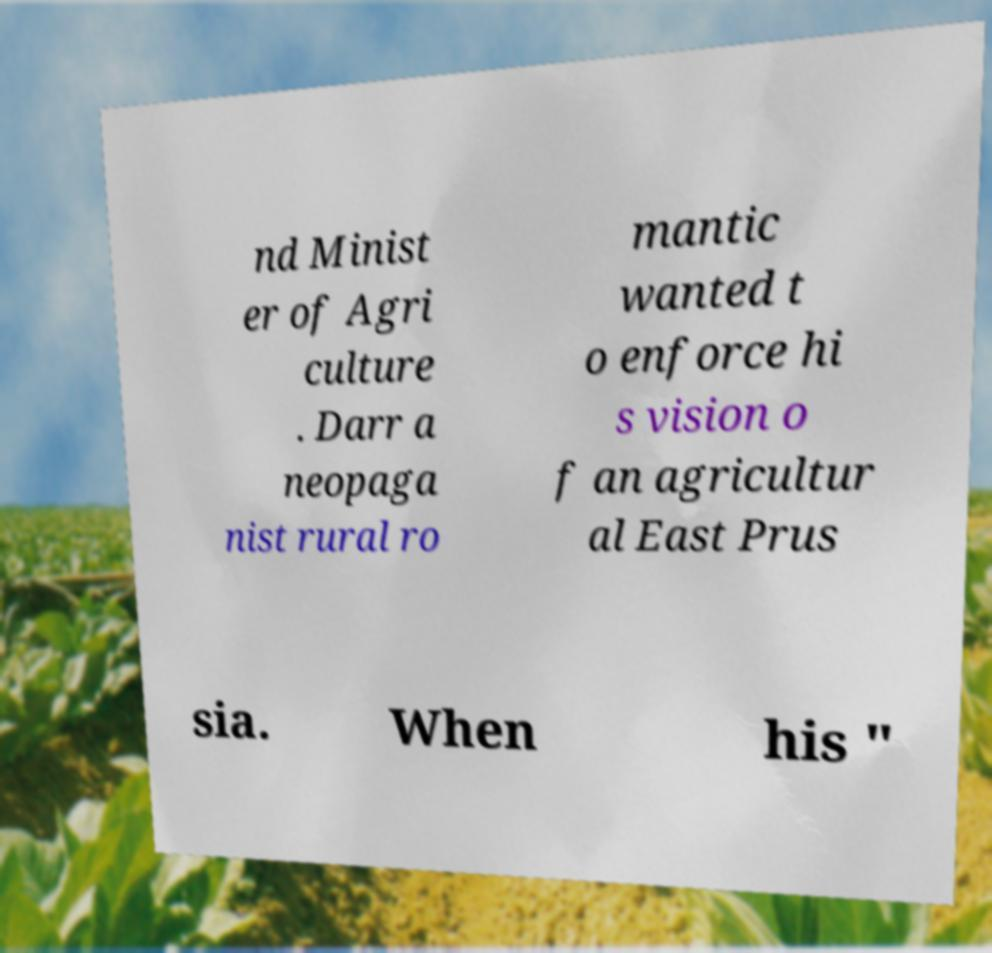Can you read and provide the text displayed in the image?This photo seems to have some interesting text. Can you extract and type it out for me? nd Minist er of Agri culture . Darr a neopaga nist rural ro mantic wanted t o enforce hi s vision o f an agricultur al East Prus sia. When his " 